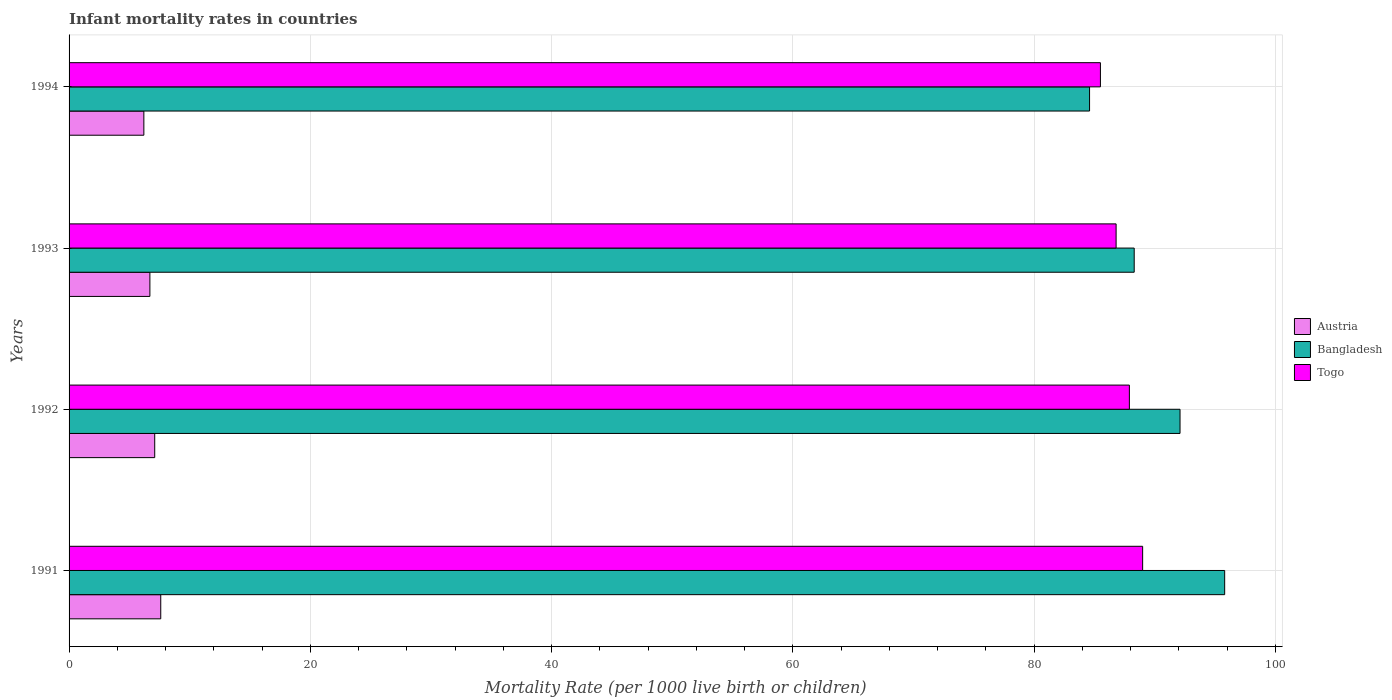How many groups of bars are there?
Make the answer very short. 4. How many bars are there on the 2nd tick from the bottom?
Ensure brevity in your answer.  3. What is the label of the 3rd group of bars from the top?
Offer a very short reply. 1992. What is the infant mortality rate in Austria in 1994?
Provide a short and direct response. 6.2. In which year was the infant mortality rate in Austria minimum?
Your answer should be very brief. 1994. What is the total infant mortality rate in Togo in the graph?
Your answer should be very brief. 349.2. What is the difference between the infant mortality rate in Togo in 1992 and that in 1994?
Offer a terse response. 2.4. What is the difference between the infant mortality rate in Austria in 1994 and the infant mortality rate in Togo in 1992?
Give a very brief answer. -81.7. What is the average infant mortality rate in Togo per year?
Offer a terse response. 87.3. In how many years, is the infant mortality rate in Togo greater than 44 ?
Provide a succinct answer. 4. What is the ratio of the infant mortality rate in Togo in 1992 to that in 1993?
Your response must be concise. 1.01. Is the infant mortality rate in Bangladesh in 1991 less than that in 1993?
Your answer should be very brief. No. What is the difference between the highest and the second highest infant mortality rate in Togo?
Your answer should be very brief. 1.1. What is the difference between the highest and the lowest infant mortality rate in Austria?
Make the answer very short. 1.4. Is the sum of the infant mortality rate in Togo in 1993 and 1994 greater than the maximum infant mortality rate in Bangladesh across all years?
Your answer should be very brief. Yes. How many years are there in the graph?
Offer a terse response. 4. What is the difference between two consecutive major ticks on the X-axis?
Your answer should be compact. 20. Are the values on the major ticks of X-axis written in scientific E-notation?
Your response must be concise. No. Does the graph contain any zero values?
Give a very brief answer. No. Does the graph contain grids?
Make the answer very short. Yes. What is the title of the graph?
Your answer should be very brief. Infant mortality rates in countries. Does "Colombia" appear as one of the legend labels in the graph?
Your answer should be compact. No. What is the label or title of the X-axis?
Make the answer very short. Mortality Rate (per 1000 live birth or children). What is the label or title of the Y-axis?
Give a very brief answer. Years. What is the Mortality Rate (per 1000 live birth or children) in Bangladesh in 1991?
Offer a very short reply. 95.8. What is the Mortality Rate (per 1000 live birth or children) in Togo in 1991?
Keep it short and to the point. 89. What is the Mortality Rate (per 1000 live birth or children) in Austria in 1992?
Your response must be concise. 7.1. What is the Mortality Rate (per 1000 live birth or children) in Bangladesh in 1992?
Make the answer very short. 92.1. What is the Mortality Rate (per 1000 live birth or children) in Togo in 1992?
Give a very brief answer. 87.9. What is the Mortality Rate (per 1000 live birth or children) in Bangladesh in 1993?
Your answer should be very brief. 88.3. What is the Mortality Rate (per 1000 live birth or children) of Togo in 1993?
Ensure brevity in your answer.  86.8. What is the Mortality Rate (per 1000 live birth or children) in Bangladesh in 1994?
Give a very brief answer. 84.6. What is the Mortality Rate (per 1000 live birth or children) of Togo in 1994?
Ensure brevity in your answer.  85.5. Across all years, what is the maximum Mortality Rate (per 1000 live birth or children) of Austria?
Your answer should be compact. 7.6. Across all years, what is the maximum Mortality Rate (per 1000 live birth or children) in Bangladesh?
Make the answer very short. 95.8. Across all years, what is the maximum Mortality Rate (per 1000 live birth or children) of Togo?
Offer a very short reply. 89. Across all years, what is the minimum Mortality Rate (per 1000 live birth or children) in Bangladesh?
Offer a terse response. 84.6. Across all years, what is the minimum Mortality Rate (per 1000 live birth or children) of Togo?
Your answer should be very brief. 85.5. What is the total Mortality Rate (per 1000 live birth or children) of Austria in the graph?
Offer a terse response. 27.6. What is the total Mortality Rate (per 1000 live birth or children) of Bangladesh in the graph?
Provide a succinct answer. 360.8. What is the total Mortality Rate (per 1000 live birth or children) of Togo in the graph?
Offer a very short reply. 349.2. What is the difference between the Mortality Rate (per 1000 live birth or children) in Austria in 1991 and that in 1992?
Your answer should be compact. 0.5. What is the difference between the Mortality Rate (per 1000 live birth or children) in Bangladesh in 1991 and that in 1992?
Offer a terse response. 3.7. What is the difference between the Mortality Rate (per 1000 live birth or children) in Bangladesh in 1991 and that in 1993?
Make the answer very short. 7.5. What is the difference between the Mortality Rate (per 1000 live birth or children) of Austria in 1991 and that in 1994?
Offer a terse response. 1.4. What is the difference between the Mortality Rate (per 1000 live birth or children) in Togo in 1991 and that in 1994?
Make the answer very short. 3.5. What is the difference between the Mortality Rate (per 1000 live birth or children) of Austria in 1992 and that in 1993?
Ensure brevity in your answer.  0.4. What is the difference between the Mortality Rate (per 1000 live birth or children) of Togo in 1992 and that in 1993?
Offer a very short reply. 1.1. What is the difference between the Mortality Rate (per 1000 live birth or children) in Austria in 1992 and that in 1994?
Offer a terse response. 0.9. What is the difference between the Mortality Rate (per 1000 live birth or children) in Bangladesh in 1993 and that in 1994?
Offer a terse response. 3.7. What is the difference between the Mortality Rate (per 1000 live birth or children) in Togo in 1993 and that in 1994?
Make the answer very short. 1.3. What is the difference between the Mortality Rate (per 1000 live birth or children) of Austria in 1991 and the Mortality Rate (per 1000 live birth or children) of Bangladesh in 1992?
Keep it short and to the point. -84.5. What is the difference between the Mortality Rate (per 1000 live birth or children) in Austria in 1991 and the Mortality Rate (per 1000 live birth or children) in Togo in 1992?
Make the answer very short. -80.3. What is the difference between the Mortality Rate (per 1000 live birth or children) in Bangladesh in 1991 and the Mortality Rate (per 1000 live birth or children) in Togo in 1992?
Your response must be concise. 7.9. What is the difference between the Mortality Rate (per 1000 live birth or children) in Austria in 1991 and the Mortality Rate (per 1000 live birth or children) in Bangladesh in 1993?
Offer a very short reply. -80.7. What is the difference between the Mortality Rate (per 1000 live birth or children) of Austria in 1991 and the Mortality Rate (per 1000 live birth or children) of Togo in 1993?
Keep it short and to the point. -79.2. What is the difference between the Mortality Rate (per 1000 live birth or children) in Austria in 1991 and the Mortality Rate (per 1000 live birth or children) in Bangladesh in 1994?
Your answer should be very brief. -77. What is the difference between the Mortality Rate (per 1000 live birth or children) of Austria in 1991 and the Mortality Rate (per 1000 live birth or children) of Togo in 1994?
Provide a succinct answer. -77.9. What is the difference between the Mortality Rate (per 1000 live birth or children) of Bangladesh in 1991 and the Mortality Rate (per 1000 live birth or children) of Togo in 1994?
Offer a terse response. 10.3. What is the difference between the Mortality Rate (per 1000 live birth or children) in Austria in 1992 and the Mortality Rate (per 1000 live birth or children) in Bangladesh in 1993?
Give a very brief answer. -81.2. What is the difference between the Mortality Rate (per 1000 live birth or children) in Austria in 1992 and the Mortality Rate (per 1000 live birth or children) in Togo in 1993?
Ensure brevity in your answer.  -79.7. What is the difference between the Mortality Rate (per 1000 live birth or children) in Austria in 1992 and the Mortality Rate (per 1000 live birth or children) in Bangladesh in 1994?
Your answer should be compact. -77.5. What is the difference between the Mortality Rate (per 1000 live birth or children) in Austria in 1992 and the Mortality Rate (per 1000 live birth or children) in Togo in 1994?
Make the answer very short. -78.4. What is the difference between the Mortality Rate (per 1000 live birth or children) of Bangladesh in 1992 and the Mortality Rate (per 1000 live birth or children) of Togo in 1994?
Give a very brief answer. 6.6. What is the difference between the Mortality Rate (per 1000 live birth or children) in Austria in 1993 and the Mortality Rate (per 1000 live birth or children) in Bangladesh in 1994?
Keep it short and to the point. -77.9. What is the difference between the Mortality Rate (per 1000 live birth or children) in Austria in 1993 and the Mortality Rate (per 1000 live birth or children) in Togo in 1994?
Your answer should be compact. -78.8. What is the average Mortality Rate (per 1000 live birth or children) in Austria per year?
Your answer should be compact. 6.9. What is the average Mortality Rate (per 1000 live birth or children) of Bangladesh per year?
Offer a terse response. 90.2. What is the average Mortality Rate (per 1000 live birth or children) of Togo per year?
Give a very brief answer. 87.3. In the year 1991, what is the difference between the Mortality Rate (per 1000 live birth or children) of Austria and Mortality Rate (per 1000 live birth or children) of Bangladesh?
Your response must be concise. -88.2. In the year 1991, what is the difference between the Mortality Rate (per 1000 live birth or children) of Austria and Mortality Rate (per 1000 live birth or children) of Togo?
Offer a very short reply. -81.4. In the year 1992, what is the difference between the Mortality Rate (per 1000 live birth or children) of Austria and Mortality Rate (per 1000 live birth or children) of Bangladesh?
Offer a very short reply. -85. In the year 1992, what is the difference between the Mortality Rate (per 1000 live birth or children) in Austria and Mortality Rate (per 1000 live birth or children) in Togo?
Your answer should be very brief. -80.8. In the year 1993, what is the difference between the Mortality Rate (per 1000 live birth or children) of Austria and Mortality Rate (per 1000 live birth or children) of Bangladesh?
Your answer should be compact. -81.6. In the year 1993, what is the difference between the Mortality Rate (per 1000 live birth or children) in Austria and Mortality Rate (per 1000 live birth or children) in Togo?
Ensure brevity in your answer.  -80.1. In the year 1994, what is the difference between the Mortality Rate (per 1000 live birth or children) of Austria and Mortality Rate (per 1000 live birth or children) of Bangladesh?
Offer a terse response. -78.4. In the year 1994, what is the difference between the Mortality Rate (per 1000 live birth or children) of Austria and Mortality Rate (per 1000 live birth or children) of Togo?
Your answer should be compact. -79.3. What is the ratio of the Mortality Rate (per 1000 live birth or children) in Austria in 1991 to that in 1992?
Offer a terse response. 1.07. What is the ratio of the Mortality Rate (per 1000 live birth or children) of Bangladesh in 1991 to that in 1992?
Make the answer very short. 1.04. What is the ratio of the Mortality Rate (per 1000 live birth or children) in Togo in 1991 to that in 1992?
Keep it short and to the point. 1.01. What is the ratio of the Mortality Rate (per 1000 live birth or children) in Austria in 1991 to that in 1993?
Your answer should be compact. 1.13. What is the ratio of the Mortality Rate (per 1000 live birth or children) of Bangladesh in 1991 to that in 1993?
Your answer should be very brief. 1.08. What is the ratio of the Mortality Rate (per 1000 live birth or children) of Togo in 1991 to that in 1993?
Give a very brief answer. 1.03. What is the ratio of the Mortality Rate (per 1000 live birth or children) in Austria in 1991 to that in 1994?
Make the answer very short. 1.23. What is the ratio of the Mortality Rate (per 1000 live birth or children) of Bangladesh in 1991 to that in 1994?
Your answer should be compact. 1.13. What is the ratio of the Mortality Rate (per 1000 live birth or children) in Togo in 1991 to that in 1994?
Your answer should be very brief. 1.04. What is the ratio of the Mortality Rate (per 1000 live birth or children) in Austria in 1992 to that in 1993?
Keep it short and to the point. 1.06. What is the ratio of the Mortality Rate (per 1000 live birth or children) of Bangladesh in 1992 to that in 1993?
Your answer should be very brief. 1.04. What is the ratio of the Mortality Rate (per 1000 live birth or children) of Togo in 1992 to that in 1993?
Give a very brief answer. 1.01. What is the ratio of the Mortality Rate (per 1000 live birth or children) of Austria in 1992 to that in 1994?
Provide a succinct answer. 1.15. What is the ratio of the Mortality Rate (per 1000 live birth or children) of Bangladesh in 1992 to that in 1994?
Offer a terse response. 1.09. What is the ratio of the Mortality Rate (per 1000 live birth or children) in Togo in 1992 to that in 1994?
Your answer should be very brief. 1.03. What is the ratio of the Mortality Rate (per 1000 live birth or children) in Austria in 1993 to that in 1994?
Your response must be concise. 1.08. What is the ratio of the Mortality Rate (per 1000 live birth or children) of Bangladesh in 1993 to that in 1994?
Your answer should be very brief. 1.04. What is the ratio of the Mortality Rate (per 1000 live birth or children) in Togo in 1993 to that in 1994?
Your answer should be very brief. 1.02. What is the difference between the highest and the lowest Mortality Rate (per 1000 live birth or children) of Austria?
Provide a succinct answer. 1.4. What is the difference between the highest and the lowest Mortality Rate (per 1000 live birth or children) of Togo?
Keep it short and to the point. 3.5. 